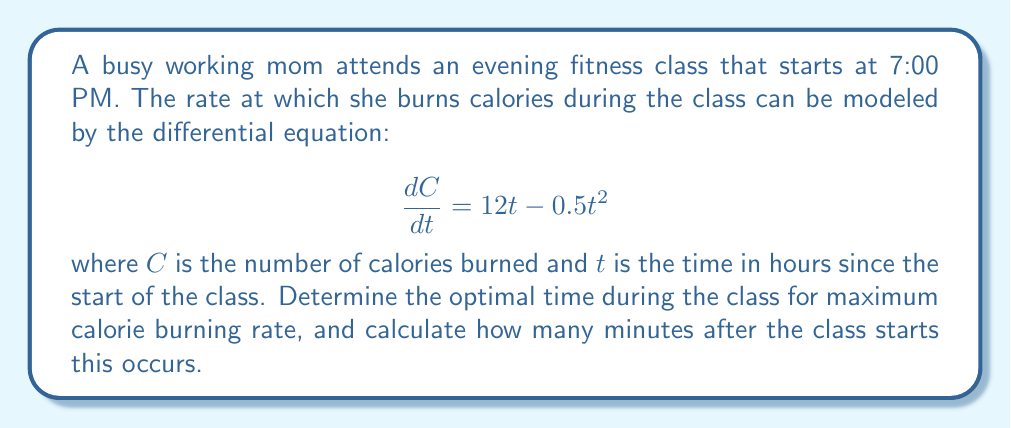Provide a solution to this math problem. To find the optimal time for maximum calorie burning rate, we need to find the maximum value of $\frac{dC}{dt}$. This can be done by differentiating $\frac{dC}{dt}$ with respect to $t$ and setting it equal to zero.

1. Differentiate $\frac{dC}{dt}$ with respect to $t$:
   $$\frac{d}{dt}\left(\frac{dC}{dt}\right) = \frac{d}{dt}(12t - 0.5t^2) = 12 - t$$

2. Set this equal to zero and solve for $t$:
   $$12 - t = 0$$
   $$t = 12$$

3. To confirm this is a maximum, we can check the second derivative:
   $$\frac{d^2}{dt^2}\left(\frac{dC}{dt}\right) = -1$$
   Since this is negative, we confirm that $t = 12$ gives a maximum.

4. Calculate how many minutes after the class starts:
   $12$ hours = $12 \times 60 = 720$ minutes

Therefore, the optimal time for maximum calorie burning rate occurs 720 minutes (12 hours) after the start of the class. However, this is well beyond the typical duration of an evening fitness class.

For a more realistic answer within the context of an evening class, we should consider the endpoint of a typical class duration, say 1 hour. The calorie burning rate at the start of the class ($t = 0$) is 0, and at the end of a 1-hour class ($t = 1$) is:

$$\frac{dC}{dt}|_{t=1} = 12(1) - 0.5(1)^2 = 11.5$$

This indicates that the calorie burning rate increases throughout a typical 1-hour class, with the maximum rate occurring at the end of the class.
Answer: The optimal time for maximum calorie burning rate during a typical 1-hour evening fitness class occurs at the end of the class, 60 minutes after it starts. 